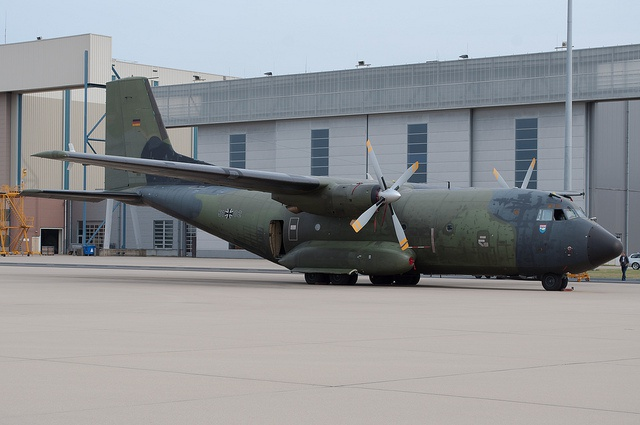Describe the objects in this image and their specific colors. I can see airplane in lightblue, black, gray, darkgray, and darkblue tones, car in lightblue, gray, darkgray, and black tones, and people in lightblue, black, gray, and blue tones in this image. 